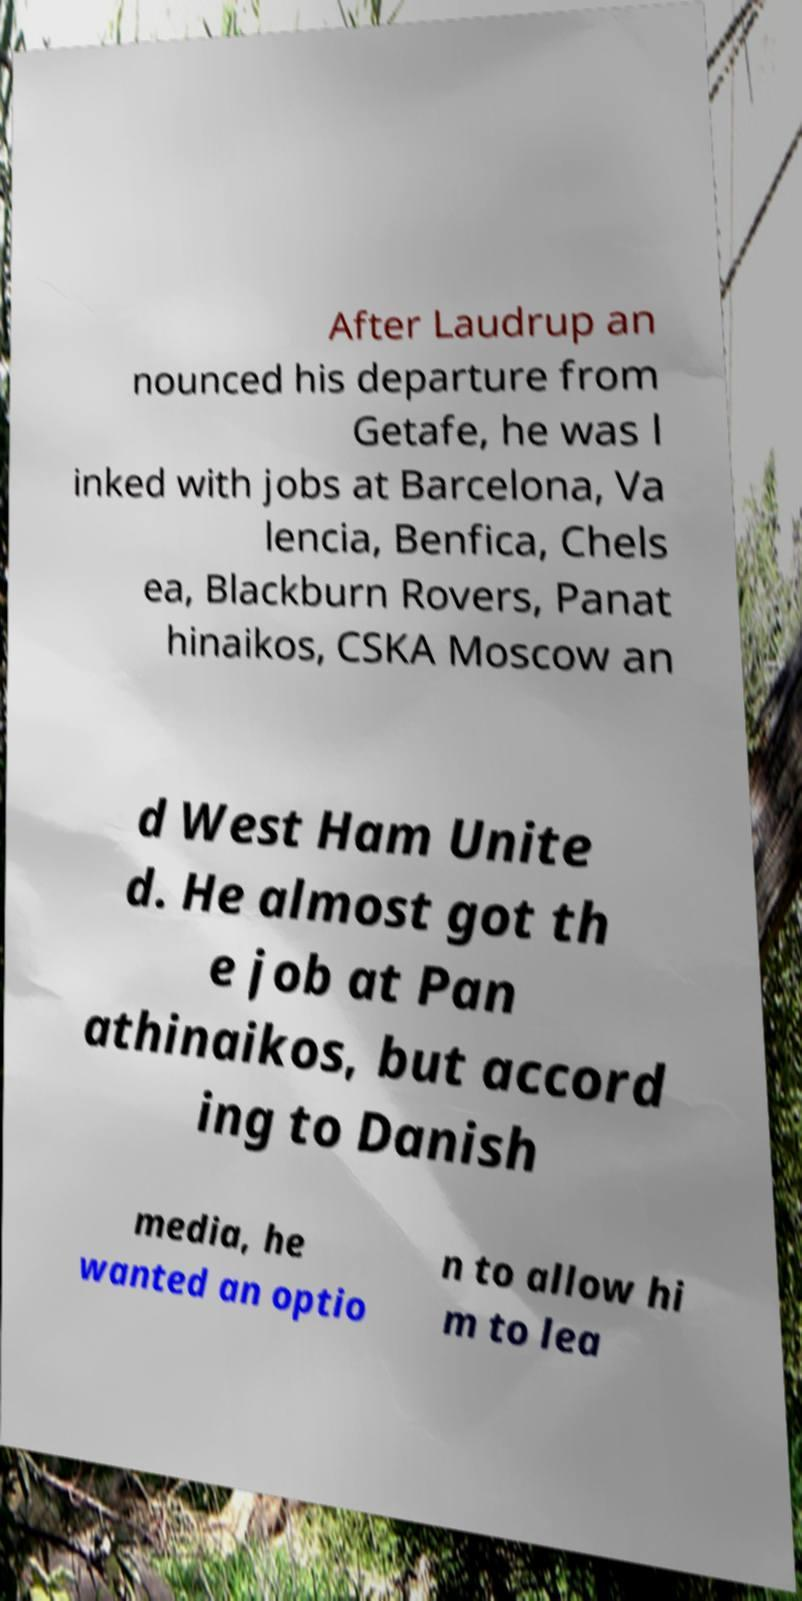Please read and relay the text visible in this image. What does it say? After Laudrup an nounced his departure from Getafe, he was l inked with jobs at Barcelona, Va lencia, Benfica, Chels ea, Blackburn Rovers, Panat hinaikos, CSKA Moscow an d West Ham Unite d. He almost got th e job at Pan athinaikos, but accord ing to Danish media, he wanted an optio n to allow hi m to lea 